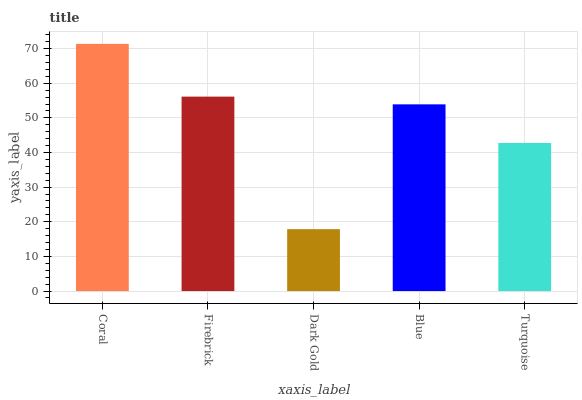Is Dark Gold the minimum?
Answer yes or no. Yes. Is Coral the maximum?
Answer yes or no. Yes. Is Firebrick the minimum?
Answer yes or no. No. Is Firebrick the maximum?
Answer yes or no. No. Is Coral greater than Firebrick?
Answer yes or no. Yes. Is Firebrick less than Coral?
Answer yes or no. Yes. Is Firebrick greater than Coral?
Answer yes or no. No. Is Coral less than Firebrick?
Answer yes or no. No. Is Blue the high median?
Answer yes or no. Yes. Is Blue the low median?
Answer yes or no. Yes. Is Turquoise the high median?
Answer yes or no. No. Is Dark Gold the low median?
Answer yes or no. No. 